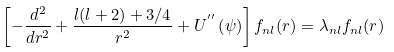Convert formula to latex. <formula><loc_0><loc_0><loc_500><loc_500>\left [ - \frac { d ^ { 2 } } { d r ^ { 2 } } + \frac { l ( l + 2 ) + 3 / 4 } { r ^ { 2 } } + U ^ { ^ { \prime \prime } } \left ( \psi \right ) \right ] f _ { n l } ( r ) = \lambda _ { n l } f _ { n l } ( r )</formula> 